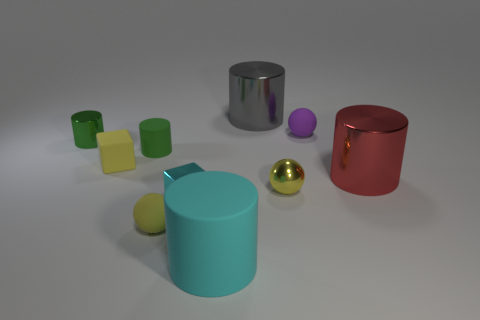Subtract all red cylinders. How many cylinders are left? 4 Subtract all green shiny cylinders. How many cylinders are left? 4 Subtract all purple cylinders. Subtract all green blocks. How many cylinders are left? 5 Subtract all blocks. How many objects are left? 8 Subtract 0 blue cylinders. How many objects are left? 10 Subtract all big gray shiny things. Subtract all large shiny cylinders. How many objects are left? 7 Add 4 tiny yellow cubes. How many tiny yellow cubes are left? 5 Add 5 tiny green metallic objects. How many tiny green metallic objects exist? 6 